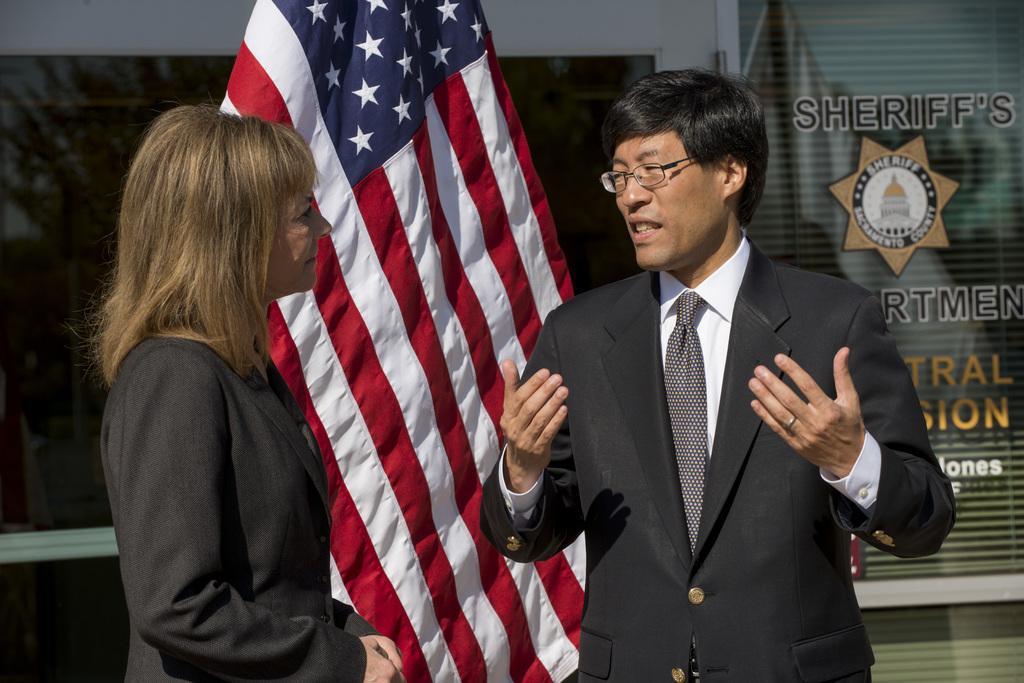Can you describe this image briefly? In this image a person and a woman are standing before a flag. Person is wearing suit, tie and spectacles. Woman is wearing a suit. Behind the flag there is a glass wall. 